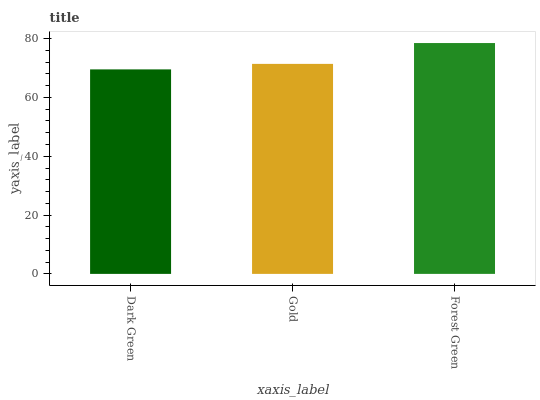Is Dark Green the minimum?
Answer yes or no. Yes. Is Forest Green the maximum?
Answer yes or no. Yes. Is Gold the minimum?
Answer yes or no. No. Is Gold the maximum?
Answer yes or no. No. Is Gold greater than Dark Green?
Answer yes or no. Yes. Is Dark Green less than Gold?
Answer yes or no. Yes. Is Dark Green greater than Gold?
Answer yes or no. No. Is Gold less than Dark Green?
Answer yes or no. No. Is Gold the high median?
Answer yes or no. Yes. Is Gold the low median?
Answer yes or no. Yes. Is Dark Green the high median?
Answer yes or no. No. Is Forest Green the low median?
Answer yes or no. No. 